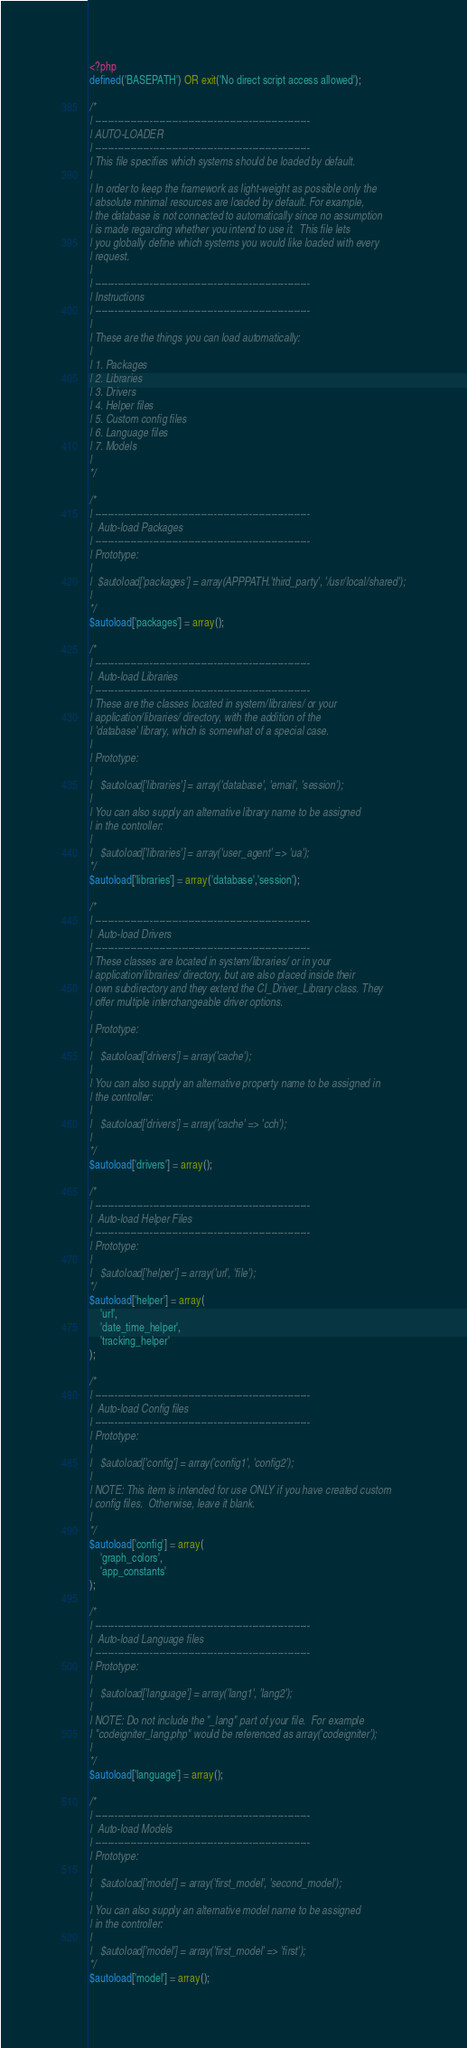Convert code to text. <code><loc_0><loc_0><loc_500><loc_500><_PHP_><?php
defined('BASEPATH') OR exit('No direct script access allowed');

/*
| -------------------------------------------------------------------
| AUTO-LOADER
| -------------------------------------------------------------------
| This file specifies which systems should be loaded by default.
|
| In order to keep the framework as light-weight as possible only the
| absolute minimal resources are loaded by default. For example,
| the database is not connected to automatically since no assumption
| is made regarding whether you intend to use it.  This file lets
| you globally define which systems you would like loaded with every
| request.
|
| -------------------------------------------------------------------
| Instructions
| -------------------------------------------------------------------
|
| These are the things you can load automatically:
|
| 1. Packages
| 2. Libraries
| 3. Drivers
| 4. Helper files
| 5. Custom config files
| 6. Language files
| 7. Models
|
*/

/*
| -------------------------------------------------------------------
|  Auto-load Packages
| -------------------------------------------------------------------
| Prototype:
|
|  $autoload['packages'] = array(APPPATH.'third_party', '/usr/local/shared');
|
*/
$autoload['packages'] = array();

/*
| -------------------------------------------------------------------
|  Auto-load Libraries
| -------------------------------------------------------------------
| These are the classes located in system/libraries/ or your
| application/libraries/ directory, with the addition of the
| 'database' library, which is somewhat of a special case.
|
| Prototype:
|
|	$autoload['libraries'] = array('database', 'email', 'session');
|
| You can also supply an alternative library name to be assigned
| in the controller:
|
|	$autoload['libraries'] = array('user_agent' => 'ua');
*/
$autoload['libraries'] = array('database','session');

/*
| -------------------------------------------------------------------
|  Auto-load Drivers
| -------------------------------------------------------------------
| These classes are located in system/libraries/ or in your
| application/libraries/ directory, but are also placed inside their
| own subdirectory and they extend the CI_Driver_Library class. They
| offer multiple interchangeable driver options.
|
| Prototype:
|
|	$autoload['drivers'] = array('cache');
|
| You can also supply an alternative property name to be assigned in
| the controller:
|
|	$autoload['drivers'] = array('cache' => 'cch');
|
*/
$autoload['drivers'] = array();

/*
| -------------------------------------------------------------------
|  Auto-load Helper Files
| -------------------------------------------------------------------
| Prototype:
|
|	$autoload['helper'] = array('url', 'file');
*/
$autoload['helper'] = array(
	'url',
	'date_time_helper',
	'tracking_helper'
);

/*
| -------------------------------------------------------------------
|  Auto-load Config files
| -------------------------------------------------------------------
| Prototype:
|
|	$autoload['config'] = array('config1', 'config2');
|
| NOTE: This item is intended for use ONLY if you have created custom
| config files.  Otherwise, leave it blank.
|
*/
$autoload['config'] = array(
	'graph_colors',
	'app_constants'
);

/*
| -------------------------------------------------------------------
|  Auto-load Language files
| -------------------------------------------------------------------
| Prototype:
|
|	$autoload['language'] = array('lang1', 'lang2');
|
| NOTE: Do not include the "_lang" part of your file.  For example
| "codeigniter_lang.php" would be referenced as array('codeigniter');
|
*/
$autoload['language'] = array();

/*
| -------------------------------------------------------------------
|  Auto-load Models
| -------------------------------------------------------------------
| Prototype:
|
|	$autoload['model'] = array('first_model', 'second_model');
|
| You can also supply an alternative model name to be assigned
| in the controller:
|
|	$autoload['model'] = array('first_model' => 'first');
*/
$autoload['model'] = array();
</code> 